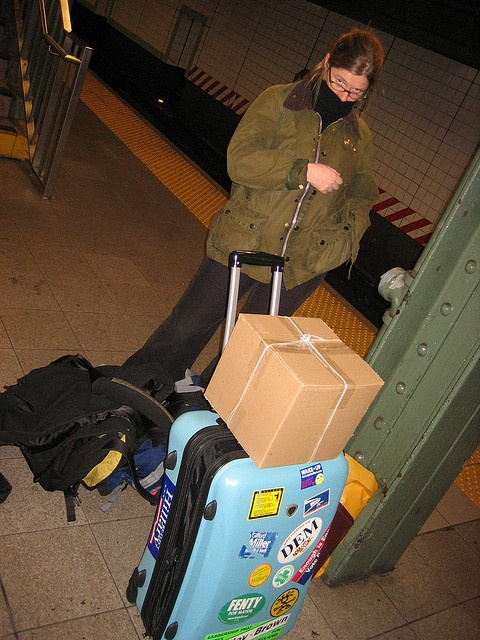Describe the objects in this image and their specific colors. I can see people in black, olive, and maroon tones, suitcase in black, lightblue, and teal tones, and backpack in black, tan, gray, and olive tones in this image. 